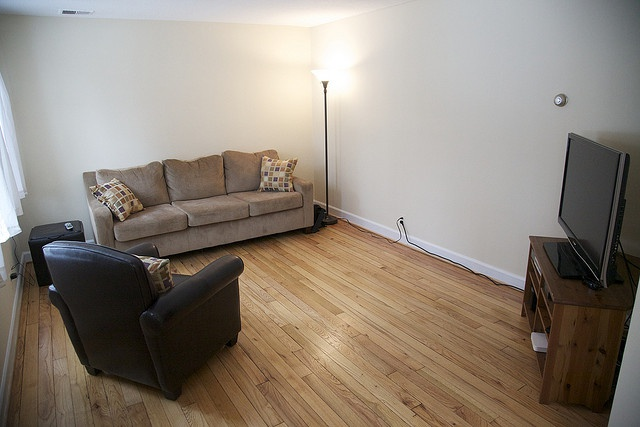Describe the objects in this image and their specific colors. I can see chair in darkgray, black, and gray tones, couch in darkgray, gray, and maroon tones, tv in darkgray, black, and gray tones, and remote in darkgray, gray, and lightblue tones in this image. 